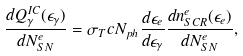Convert formula to latex. <formula><loc_0><loc_0><loc_500><loc_500>\frac { d Q _ { \gamma } ^ { I C } ( \epsilon _ { \gamma } ) } { d N _ { S N } ^ { e } } = \sigma _ { T } c N _ { p h } \frac { d \epsilon _ { e } } { d \epsilon _ { \gamma } } \frac { d n ^ { e } _ { S C R } ( \epsilon _ { e } ) } { d N _ { S N } ^ { e } } ,</formula> 